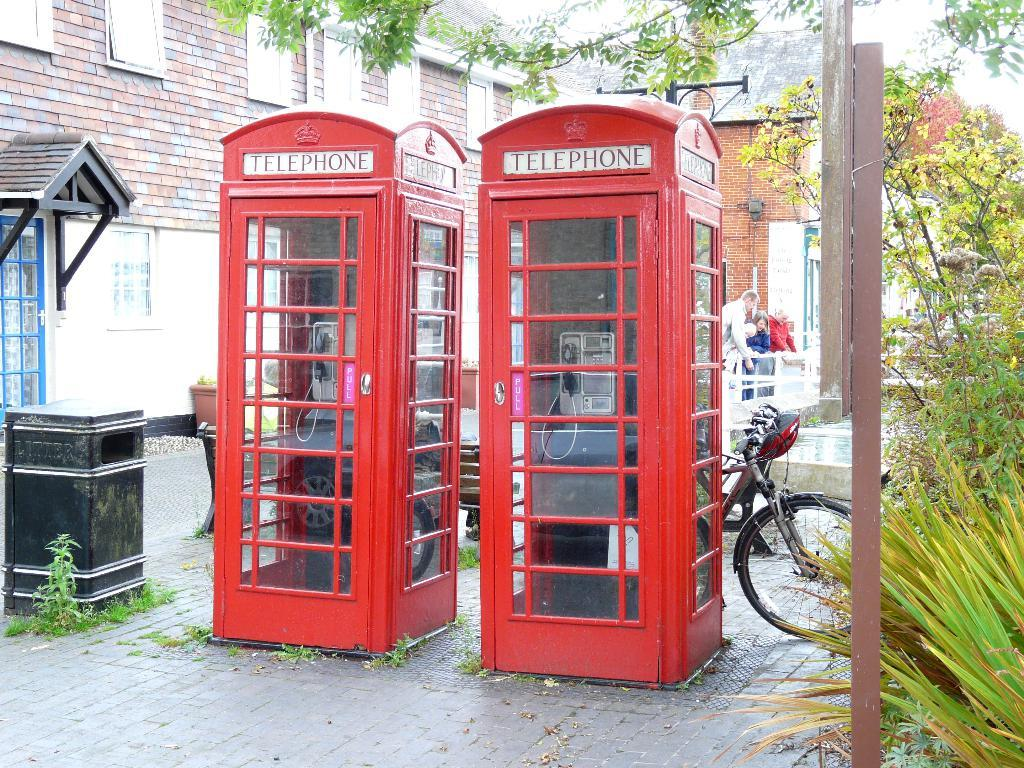What type of phone booths are in the image? There are red phone booths in the image. What mode of transportation can be seen in the image? There is a bicycle in the image. What type of vegetation is present in the image? There are plants in the image. What type of ground surface is visible in the image? The grass is visible in the image. What other objects can be seen in the image? There are other objects in the image, but their specific details are not mentioned in the facts. What can be seen in the background of the image? There are people, a building, and a fence in the background of the image. Can you see a boat floating in the water in the image? There is no water or boat present in the image. What type of music is being played by the band in the image? There is no band or music present in the image. 